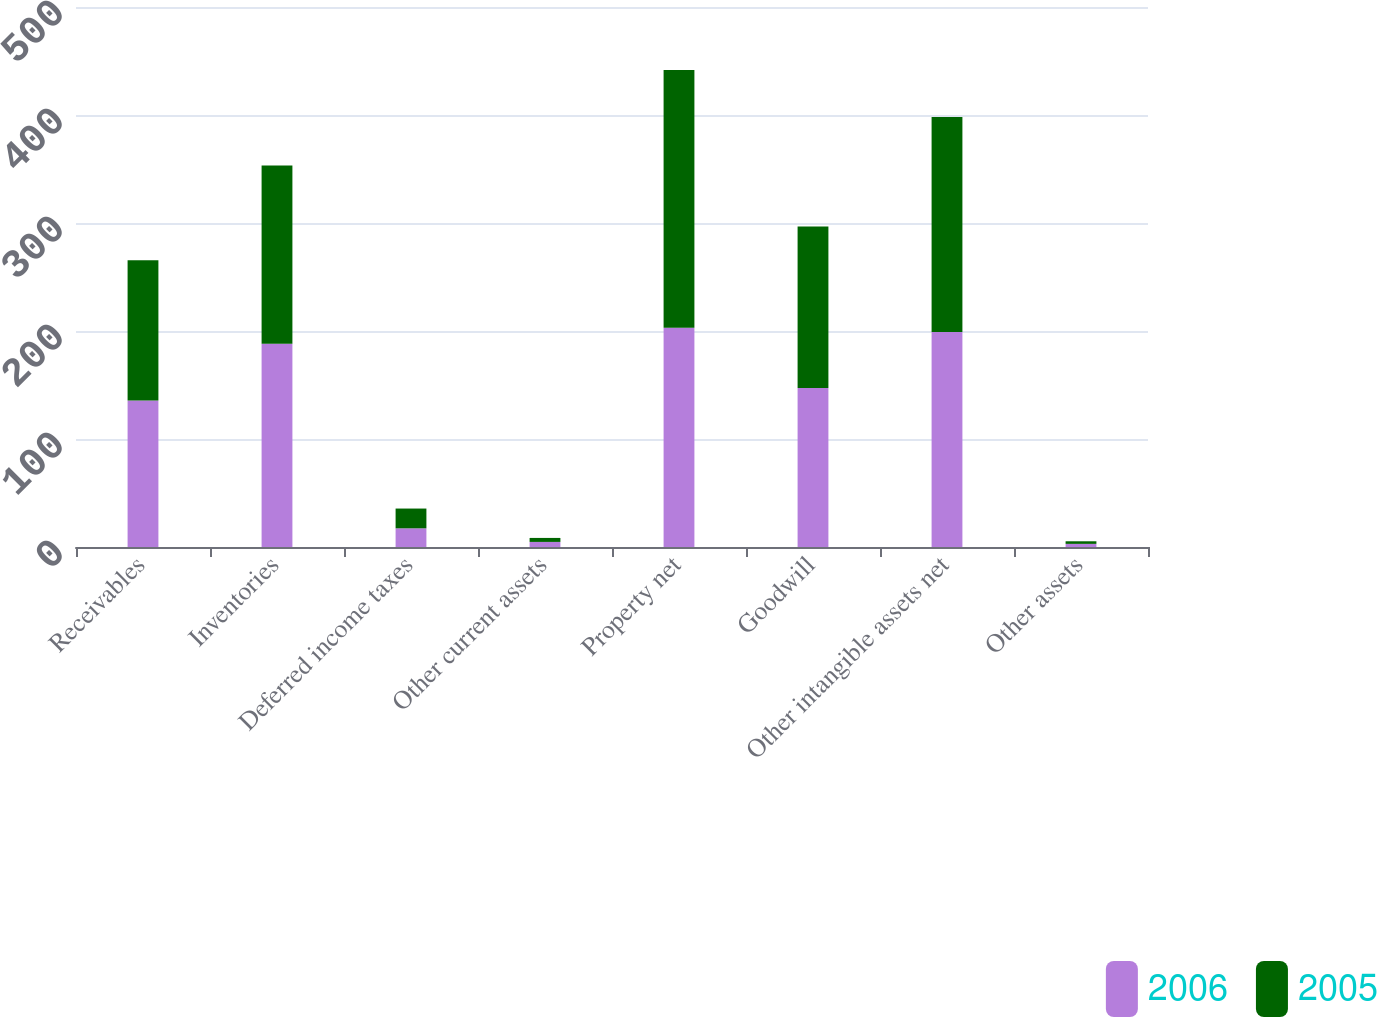Convert chart. <chart><loc_0><loc_0><loc_500><loc_500><stacked_bar_chart><ecel><fcel>Receivables<fcel>Inventories<fcel>Deferred income taxes<fcel>Other current assets<fcel>Property net<fcel>Goodwill<fcel>Other intangible assets net<fcel>Other assets<nl><fcel>2006<fcel>135.7<fcel>188.1<fcel>17.3<fcel>4.7<fcel>203.1<fcel>147.2<fcel>199<fcel>2.9<nl><fcel>2005<fcel>129.9<fcel>165.1<fcel>18.3<fcel>3.7<fcel>238.5<fcel>149.5<fcel>199.2<fcel>2.4<nl></chart> 